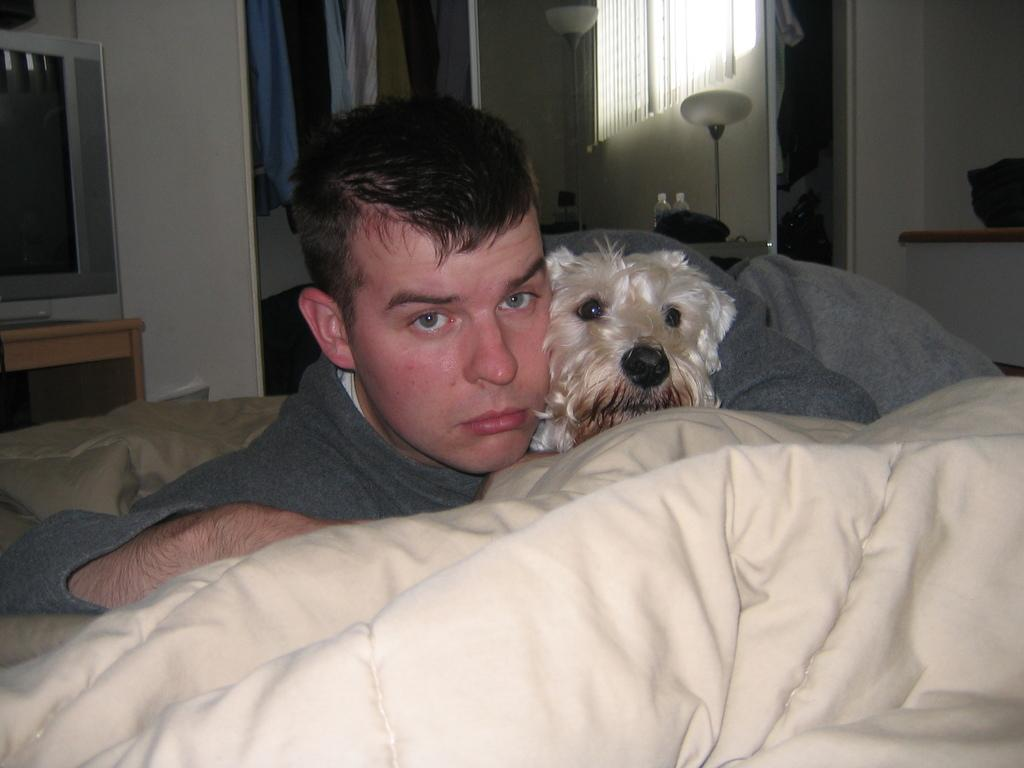What is the man doing in the image? The man is laying on his bed. Is there any other living being with the man? Yes, there is a dog with the man. What objects can be seen behind the man? There is a television and a lamp behind the man. What else is visible in the image? Clothes are present in the image. Can you tell me how many strangers are present in the image? There is no stranger present in the image; it only features a man and a dog. What type of error can be seen in the image? There is no error present in the image. 